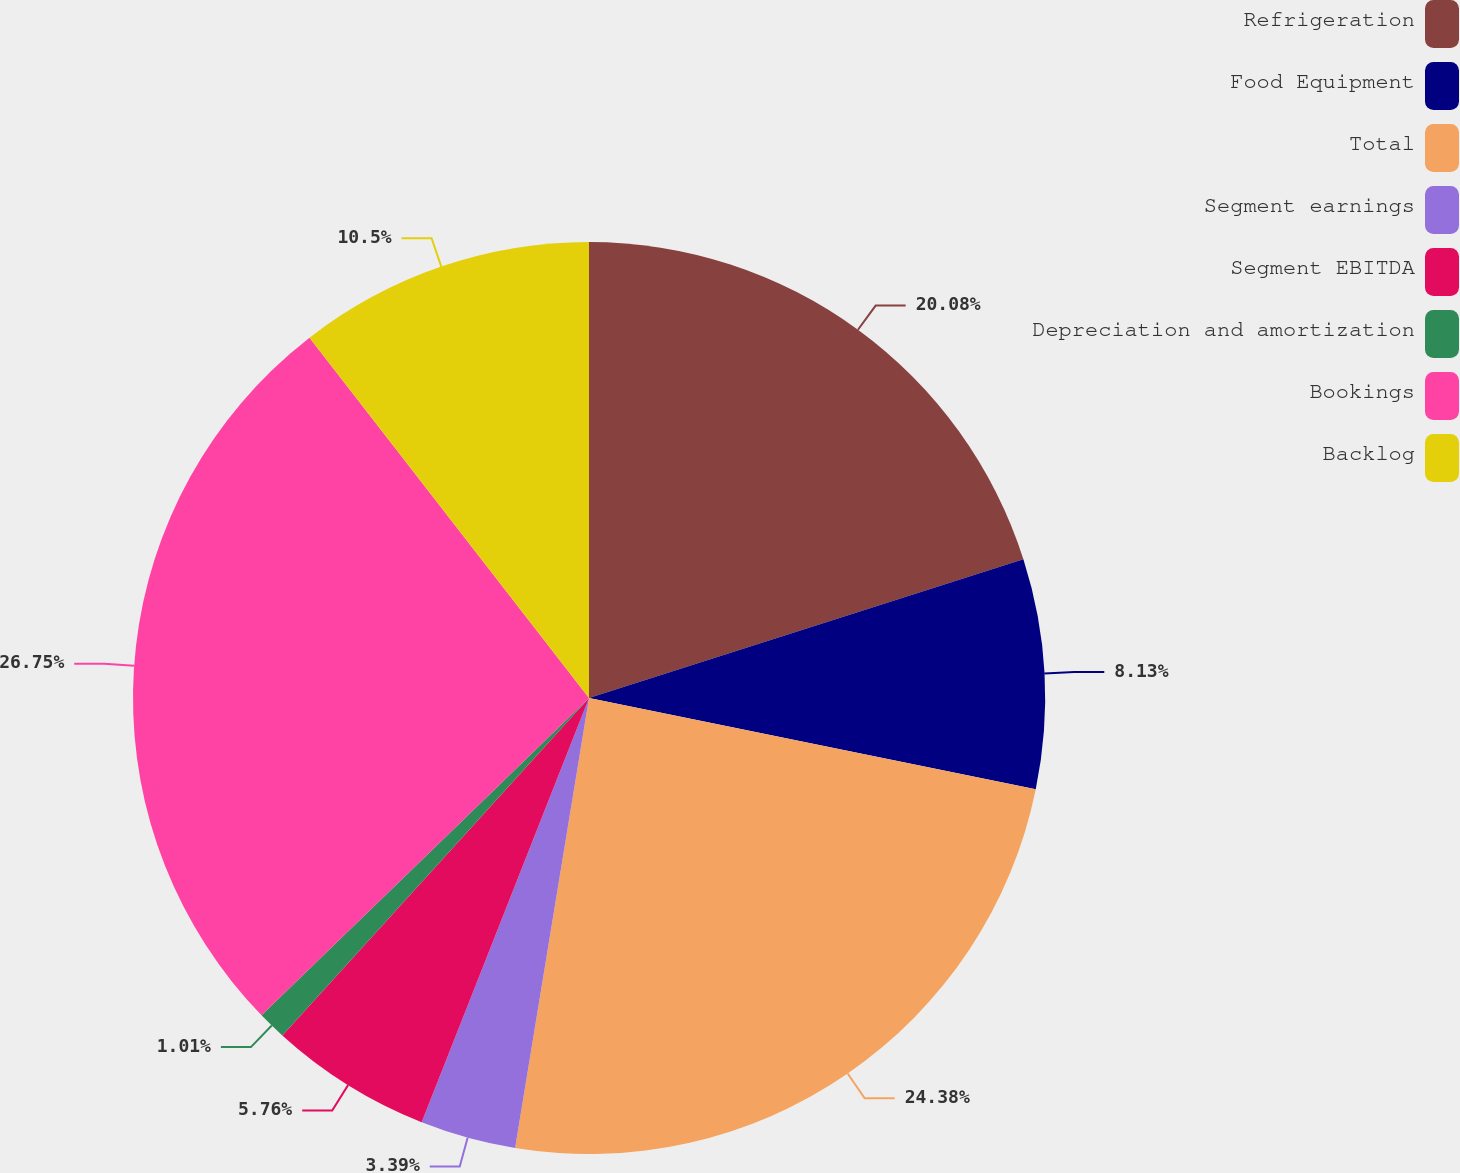Convert chart. <chart><loc_0><loc_0><loc_500><loc_500><pie_chart><fcel>Refrigeration<fcel>Food Equipment<fcel>Total<fcel>Segment earnings<fcel>Segment EBITDA<fcel>Depreciation and amortization<fcel>Bookings<fcel>Backlog<nl><fcel>20.08%<fcel>8.13%<fcel>24.38%<fcel>3.39%<fcel>5.76%<fcel>1.01%<fcel>26.75%<fcel>10.5%<nl></chart> 